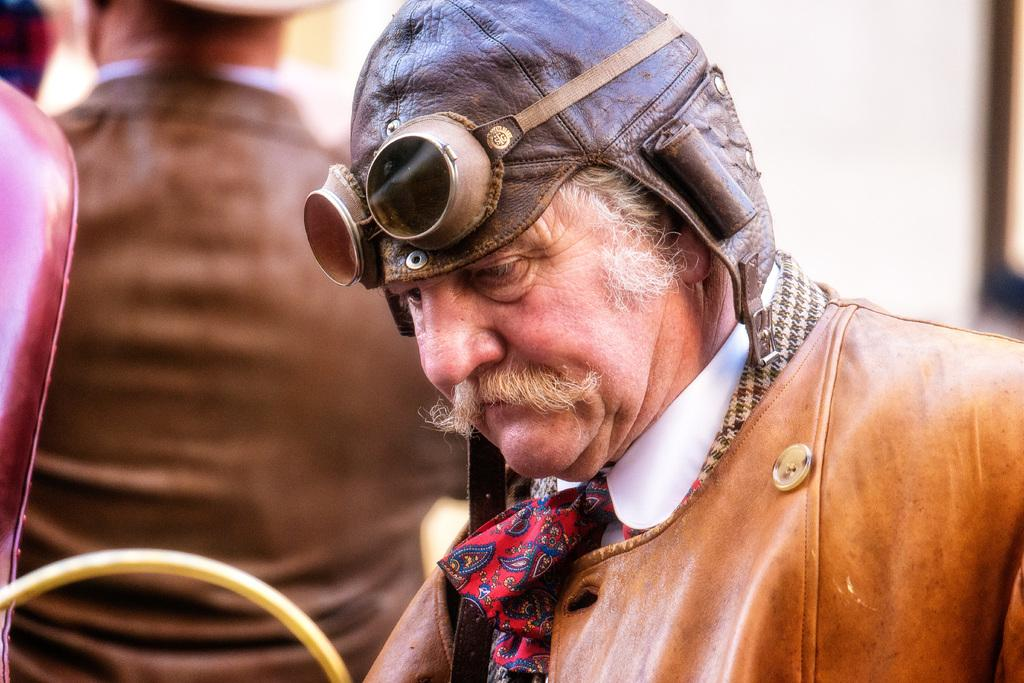How many people are visible in the image? There are two people in the front of the image. What can be observed about the background of the image? The background of the image is blurred. What type of growth can be seen on the donkey in the image? There is no donkey present in the image, so no growth can be observed. 